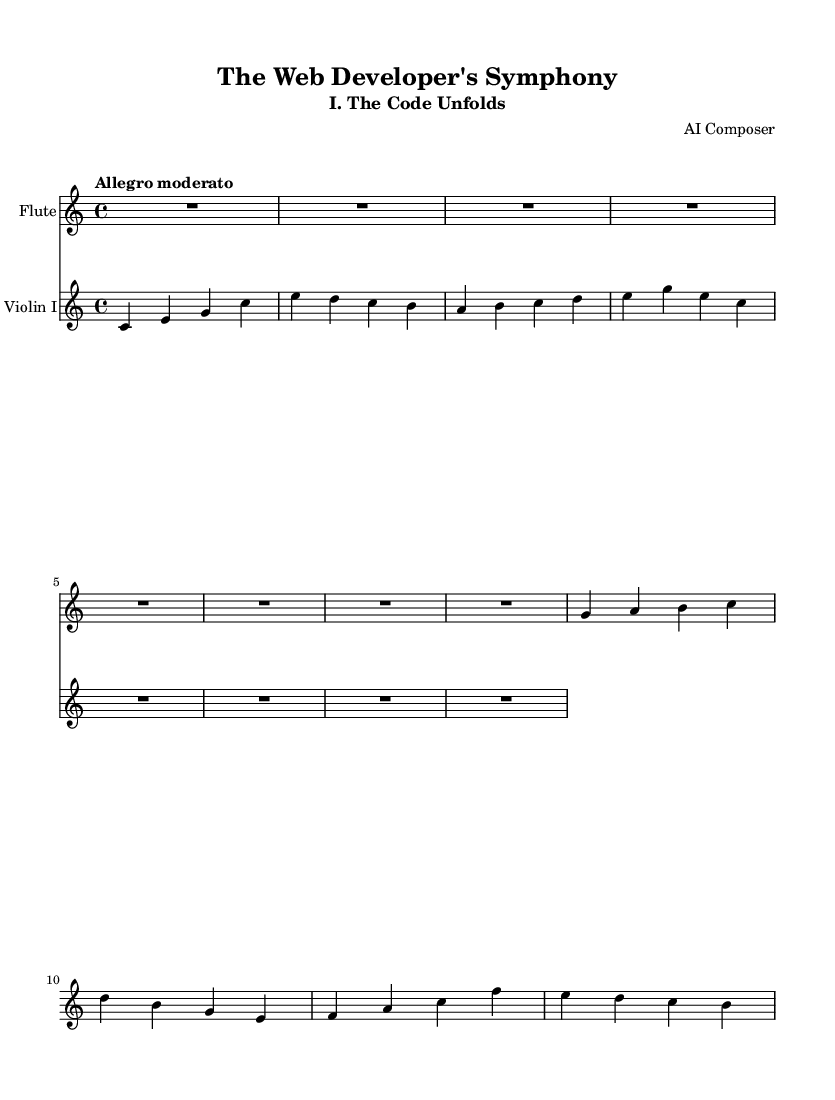What is the key signature of this music? The key signature is indicated at the beginning of the staff. It is C major, which has no sharps or flats.
Answer: C major What is the time signature of this music? The time signature appears after the key signature and is shown as 4/4, which signifies four beats in a measure and a quarter note receives one beat.
Answer: 4/4 What is the tempo marking of this music? The tempo marking is written at the beginning and is specified as "Allegro moderato," denoting a moderately fast pace.
Answer: Allegro moderato How many measures are there for the flute part? The flute part consists of a series of notes followed by a rest. By counting the segments, there are a total of four measures present.
Answer: 4 What is the highest note in the violin part? To find the highest note in the violin part, we examine the notes ascending in pitch. The note C is the highest encountered in this section.
Answer: C In which section of the symphony does this music belong? The subtitle provided states that this music is the first section of the symphony, named "I. The Code Unfolds."
Answer: I. The Code Unfolds What instruments are featured in this score? The score explicitly lists the instrument names at the start of each staff; they include "Flute" and "Violin I.”
Answer: Flute, Violin I 